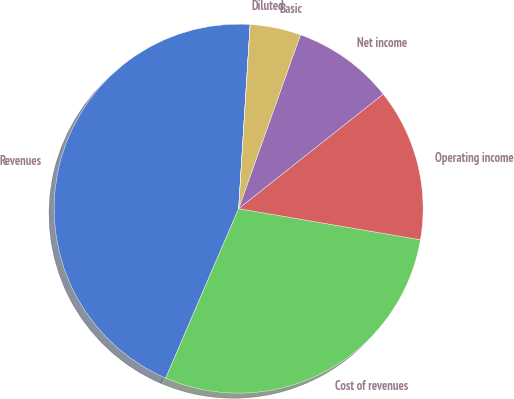Convert chart to OTSL. <chart><loc_0><loc_0><loc_500><loc_500><pie_chart><fcel>Revenues<fcel>Cost of revenues<fcel>Operating income<fcel>Net income<fcel>Basic<fcel>Diluted<nl><fcel>44.52%<fcel>28.77%<fcel>13.36%<fcel>8.9%<fcel>4.45%<fcel>0.0%<nl></chart> 